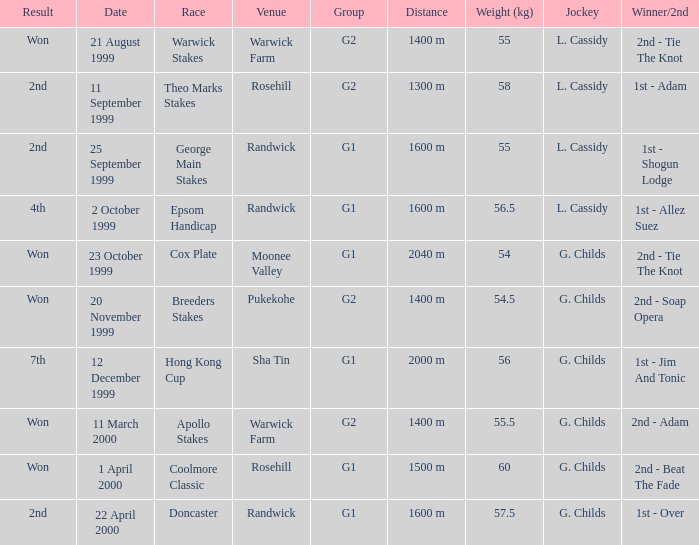What is the number of teams with a total weight of 57.5? 1.0. I'm looking to parse the entire table for insights. Could you assist me with that? {'header': ['Result', 'Date', 'Race', 'Venue', 'Group', 'Distance', 'Weight (kg)', 'Jockey', 'Winner/2nd'], 'rows': [['Won', '21 August 1999', 'Warwick Stakes', 'Warwick Farm', 'G2', '1400 m', '55', 'L. Cassidy', '2nd - Tie The Knot'], ['2nd', '11 September 1999', 'Theo Marks Stakes', 'Rosehill', 'G2', '1300 m', '58', 'L. Cassidy', '1st - Adam'], ['2nd', '25 September 1999', 'George Main Stakes', 'Randwick', 'G1', '1600 m', '55', 'L. Cassidy', '1st - Shogun Lodge'], ['4th', '2 October 1999', 'Epsom Handicap', 'Randwick', 'G1', '1600 m', '56.5', 'L. Cassidy', '1st - Allez Suez'], ['Won', '23 October 1999', 'Cox Plate', 'Moonee Valley', 'G1', '2040 m', '54', 'G. Childs', '2nd - Tie The Knot'], ['Won', '20 November 1999', 'Breeders Stakes', 'Pukekohe', 'G2', '1400 m', '54.5', 'G. Childs', '2nd - Soap Opera'], ['7th', '12 December 1999', 'Hong Kong Cup', 'Sha Tin', 'G1', '2000 m', '56', 'G. Childs', '1st - Jim And Tonic'], ['Won', '11 March 2000', 'Apollo Stakes', 'Warwick Farm', 'G2', '1400 m', '55.5', 'G. Childs', '2nd - Adam'], ['Won', '1 April 2000', 'Coolmore Classic', 'Rosehill', 'G1', '1500 m', '60', 'G. Childs', '2nd - Beat The Fade'], ['2nd', '22 April 2000', 'Doncaster', 'Randwick', 'G1', '1600 m', '57.5', 'G. Childs', '1st - Over']]} 